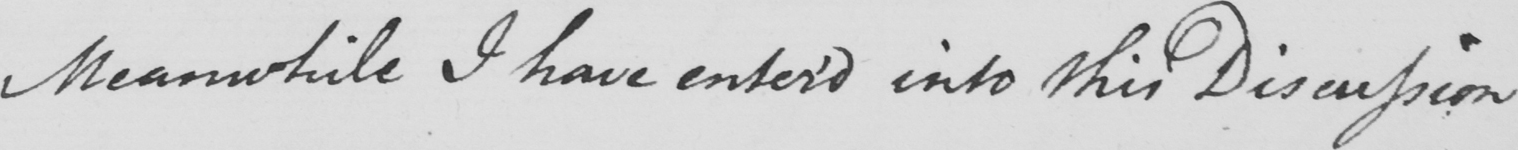What text is written in this handwritten line? Meanwhile I have entered into this Discussion 